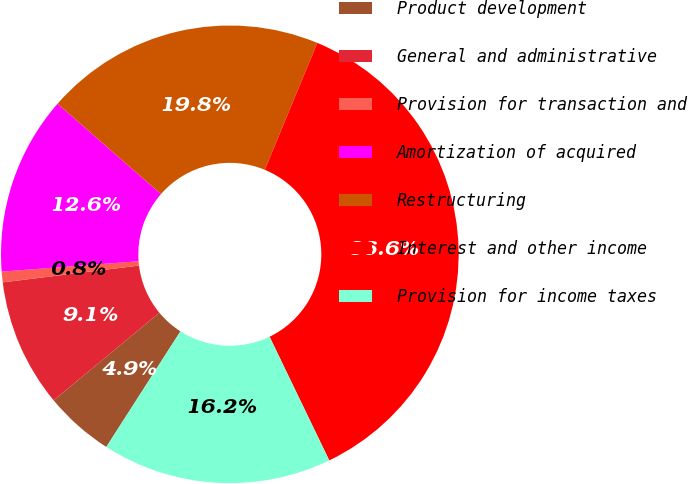<chart> <loc_0><loc_0><loc_500><loc_500><pie_chart><fcel>Product development<fcel>General and administrative<fcel>Provision for transaction and<fcel>Amortization of acquired<fcel>Restructuring<fcel>Interest and other income<fcel>Provision for income taxes<nl><fcel>4.91%<fcel>9.06%<fcel>0.75%<fcel>12.64%<fcel>19.81%<fcel>36.6%<fcel>16.23%<nl></chart> 